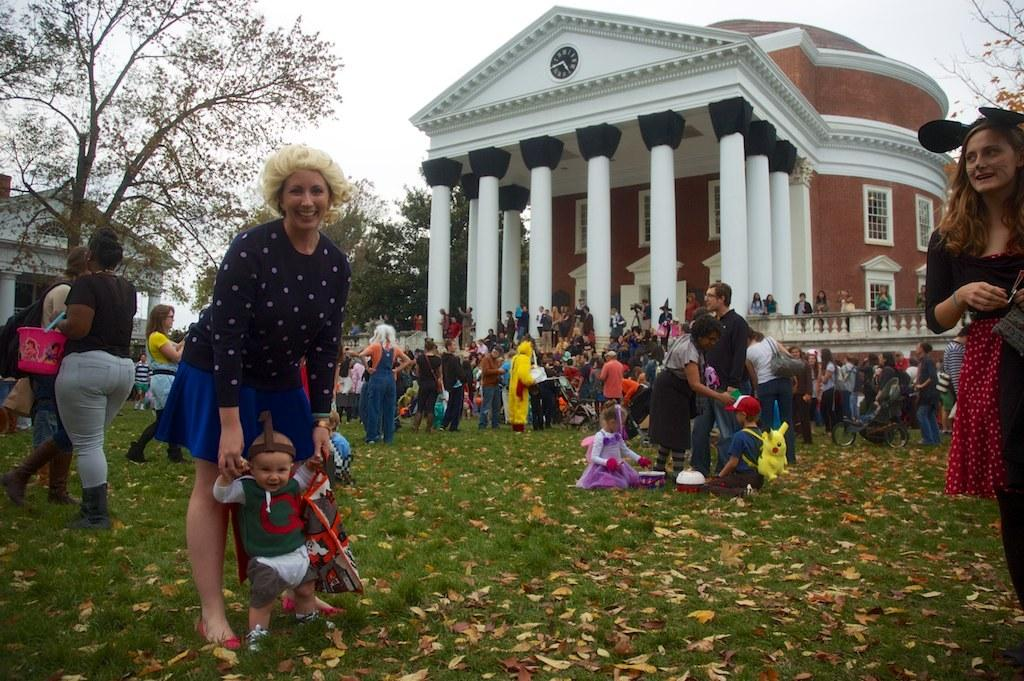What can be seen in the image in terms of people? There are groups of people in the image. What object related to children can be seen in the image? There is a stroller in the image. What is present on the grass in the image? Dry leaves are present on the grass. What can be seen in the background of the image? There are trees, buildings, pillars, and the sky visible in the background of the image. What type of drug is being sold by the people in the image? There is no indication in the image that any drugs are being sold or used. What is the source of the smoke in the image? There is no smoke present in the image. 